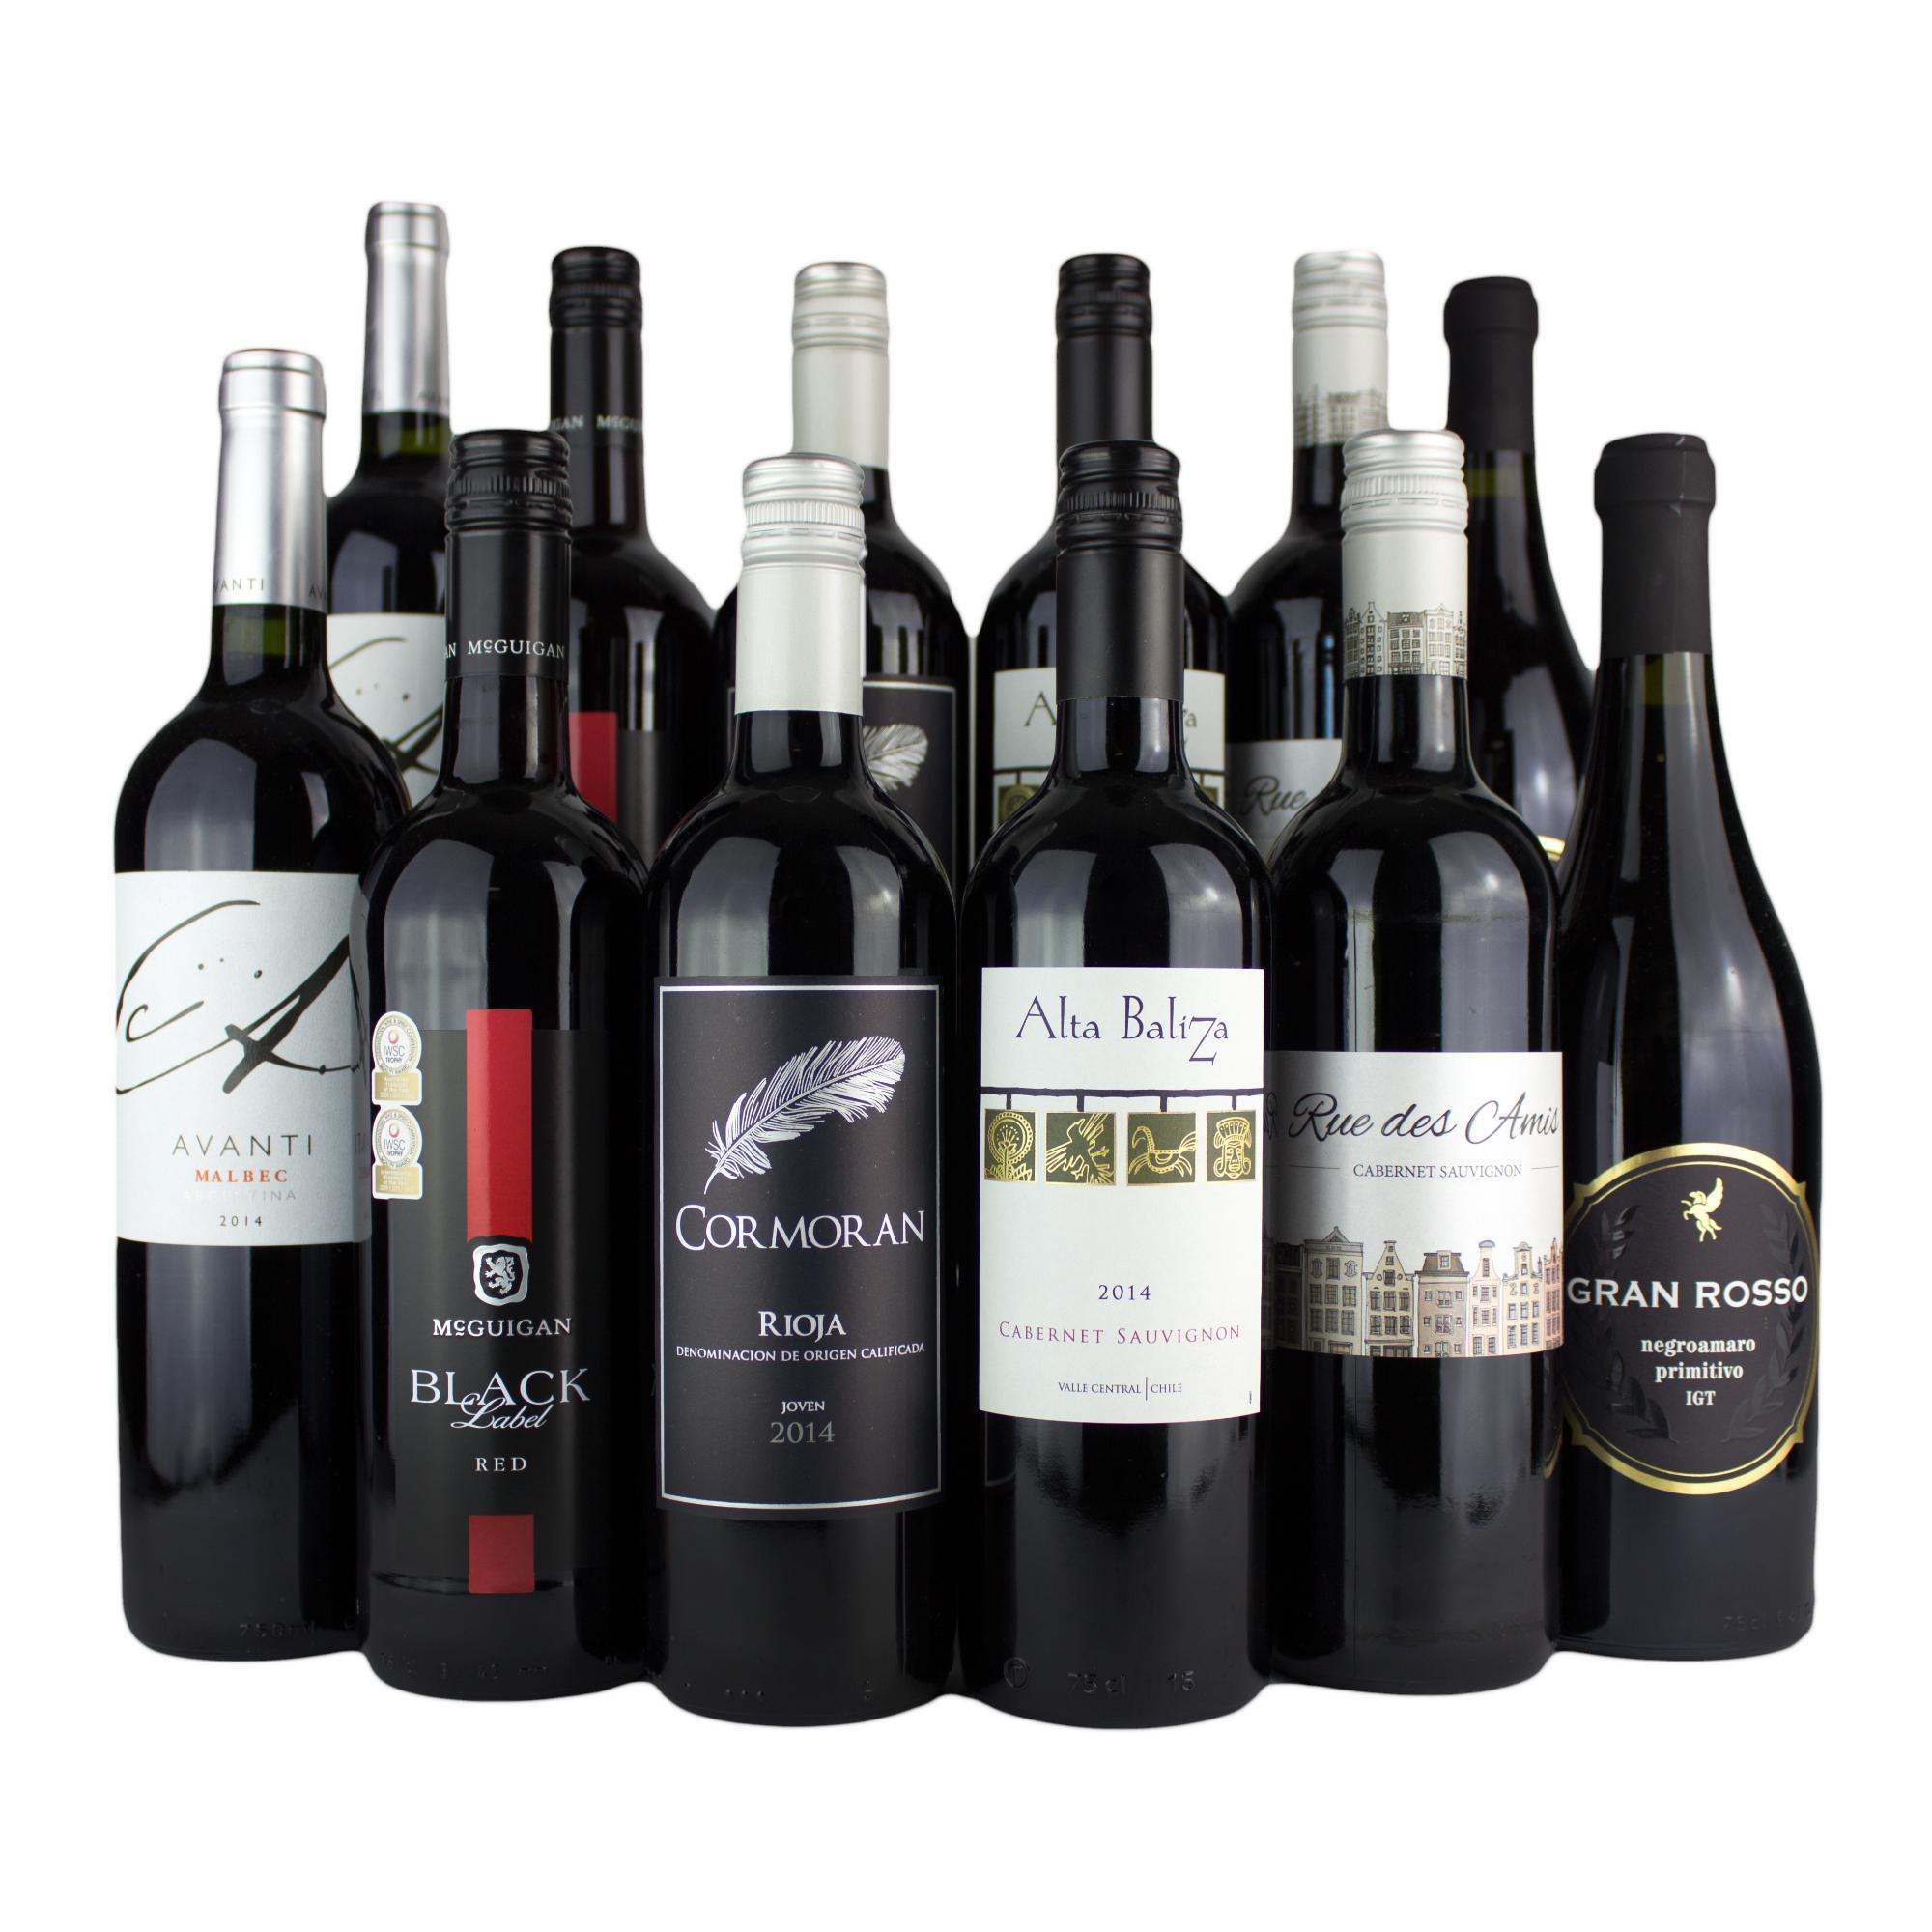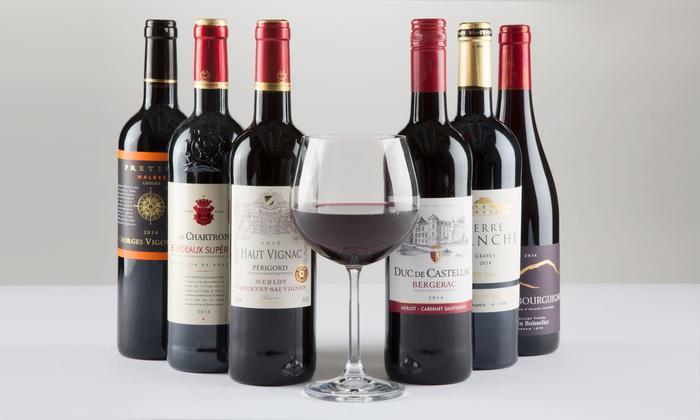The first image is the image on the left, the second image is the image on the right. Analyze the images presented: Is the assertion "The left image includes two wine glasses." valid? Answer yes or no. No. The first image is the image on the left, the second image is the image on the right. Examine the images to the left and right. Is the description "A single bottle of wine stands in the image on the left." accurate? Answer yes or no. No. 